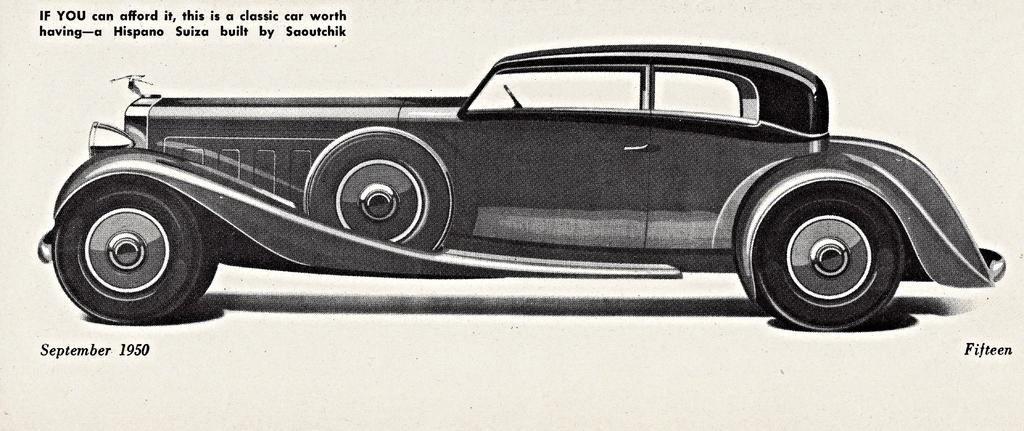What is the main subject of the image? The main subject of the image is a picture of a 1950 model car. What type of alley can be seen in the background of the image? There is no alley present in the image, as it features a picture of a 1950 model car. 